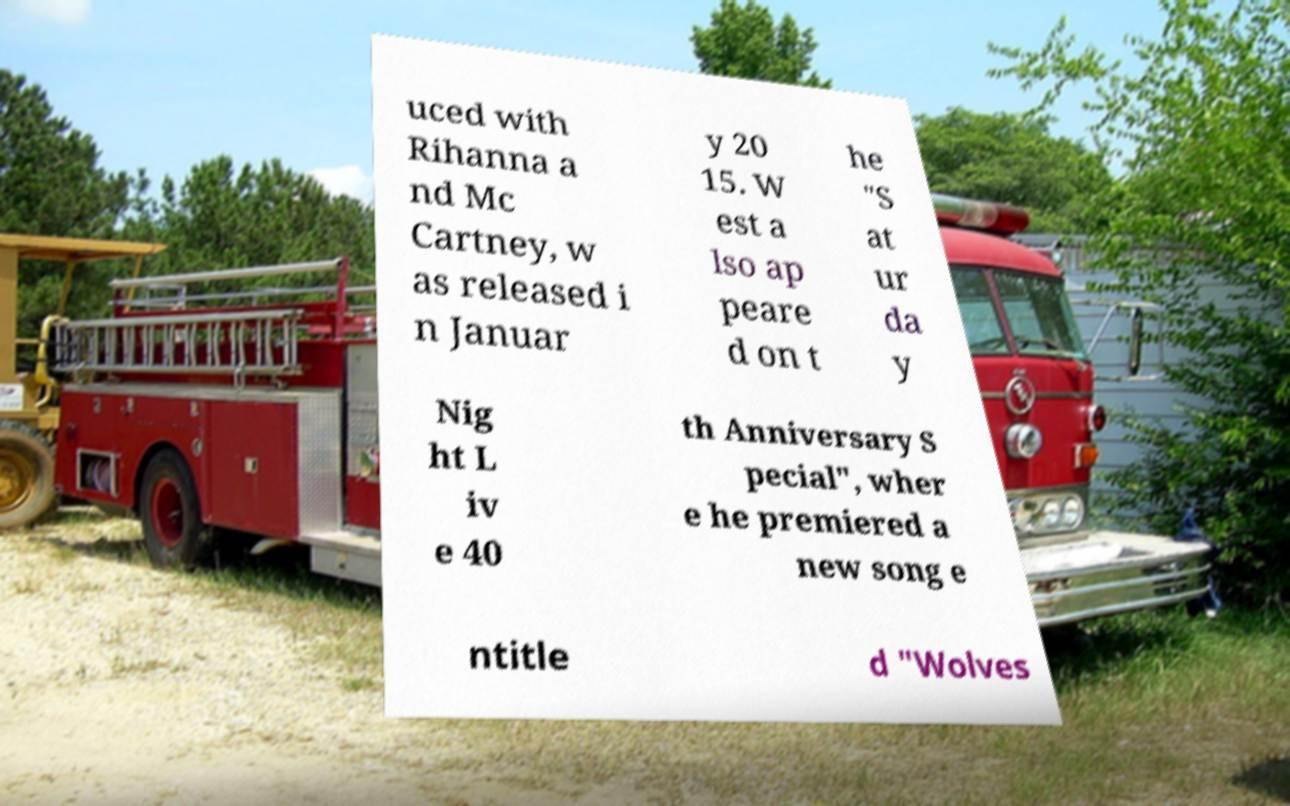I need the written content from this picture converted into text. Can you do that? uced with Rihanna a nd Mc Cartney, w as released i n Januar y 20 15. W est a lso ap peare d on t he "S at ur da y Nig ht L iv e 40 th Anniversary S pecial", wher e he premiered a new song e ntitle d "Wolves 